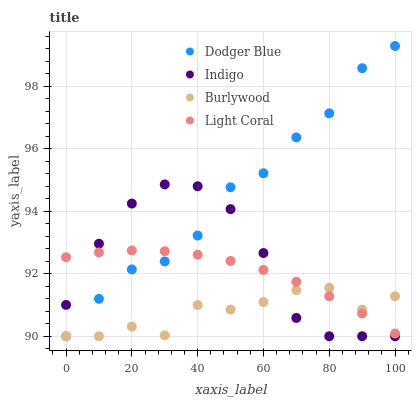Does Burlywood have the minimum area under the curve?
Answer yes or no. Yes. Does Dodger Blue have the maximum area under the curve?
Answer yes or no. Yes. Does Indigo have the minimum area under the curve?
Answer yes or no. No. Does Indigo have the maximum area under the curve?
Answer yes or no. No. Is Light Coral the smoothest?
Answer yes or no. Yes. Is Indigo the roughest?
Answer yes or no. Yes. Is Dodger Blue the smoothest?
Answer yes or no. No. Is Dodger Blue the roughest?
Answer yes or no. No. Does Burlywood have the lowest value?
Answer yes or no. Yes. Does Light Coral have the lowest value?
Answer yes or no. No. Does Dodger Blue have the highest value?
Answer yes or no. Yes. Does Indigo have the highest value?
Answer yes or no. No. Does Burlywood intersect Indigo?
Answer yes or no. Yes. Is Burlywood less than Indigo?
Answer yes or no. No. Is Burlywood greater than Indigo?
Answer yes or no. No. 